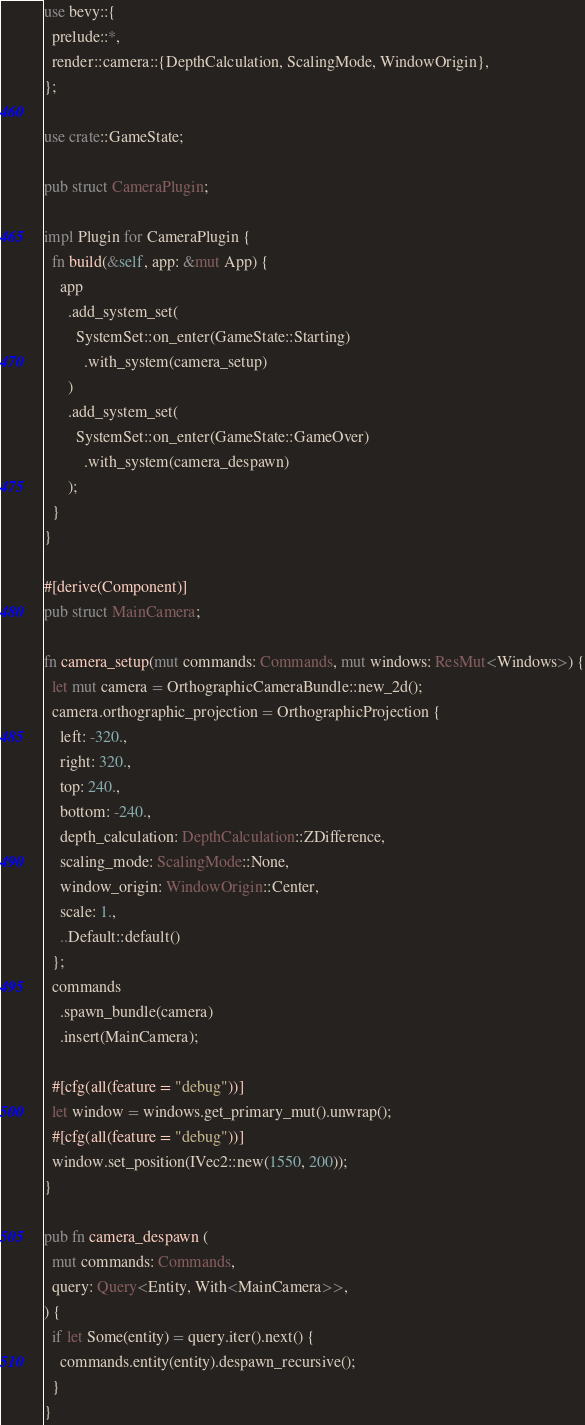Convert code to text. <code><loc_0><loc_0><loc_500><loc_500><_Rust_>use bevy::{
  prelude::*,
  render::camera::{DepthCalculation, ScalingMode, WindowOrigin},
};

use crate::GameState;

pub struct CameraPlugin;

impl Plugin for CameraPlugin {
  fn build(&self, app: &mut App) {
    app
      .add_system_set(
        SystemSet::on_enter(GameState::Starting)
          .with_system(camera_setup)
      )
      .add_system_set(
        SystemSet::on_enter(GameState::GameOver)
          .with_system(camera_despawn)
      );
  }
}

#[derive(Component)]
pub struct MainCamera;

fn camera_setup(mut commands: Commands, mut windows: ResMut<Windows>) {
  let mut camera = OrthographicCameraBundle::new_2d();
  camera.orthographic_projection = OrthographicProjection {
    left: -320.,
    right: 320.,
    top: 240.,
    bottom: -240.,
    depth_calculation: DepthCalculation::ZDifference,
    scaling_mode: ScalingMode::None,
    window_origin: WindowOrigin::Center,
    scale: 1.,
    ..Default::default()
  };
  commands
    .spawn_bundle(camera)
    .insert(MainCamera);

  #[cfg(all(feature = "debug"))]
  let window = windows.get_primary_mut().unwrap();
  #[cfg(all(feature = "debug"))]
  window.set_position(IVec2::new(1550, 200));
}

pub fn camera_despawn (
  mut commands: Commands,
  query: Query<Entity, With<MainCamera>>,
) {
  if let Some(entity) = query.iter().next() {
    commands.entity(entity).despawn_recursive();
  }
}
</code> 